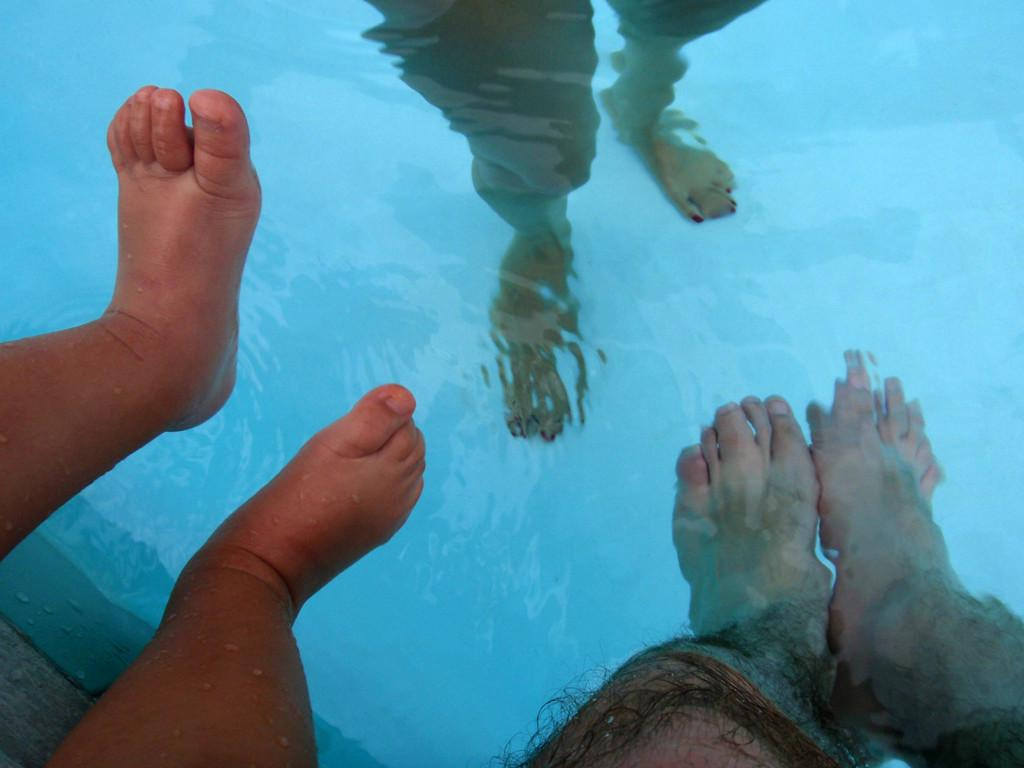How many people are in the pool in the image? There are two people in the pool in the image. What is the pool filled with? The pool contains water. Where is the kid located in the image? The kid is on the left side of the image. What part of the kid's body is visible? The kid's legs are visible. What type of pencil is the kid holding in the image? There is no pencil present in the image; the kid is in a pool with water. How many eggs are visible in the image? There are no eggs visible in the image; it features two people in a pool and a kid on the left side. 